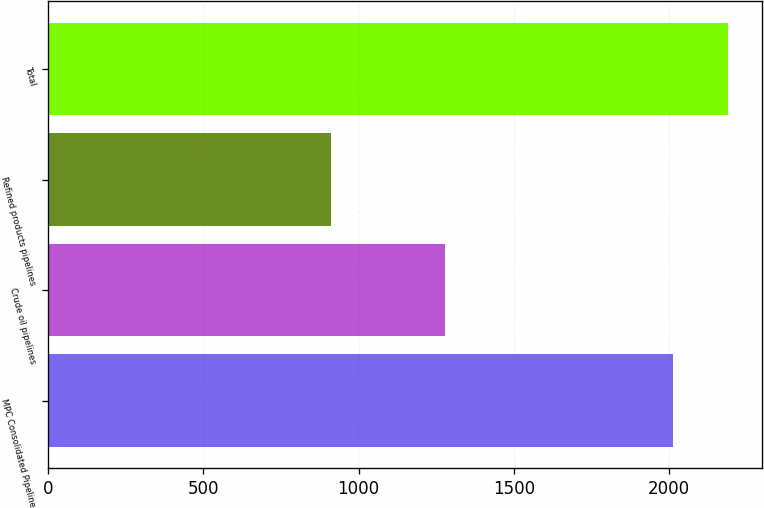Convert chart to OTSL. <chart><loc_0><loc_0><loc_500><loc_500><bar_chart><fcel>MPC Consolidated Pipeline<fcel>Crude oil pipelines<fcel>Refined products pipelines<fcel>Total<nl><fcel>2013<fcel>1280<fcel>911<fcel>2191<nl></chart> 